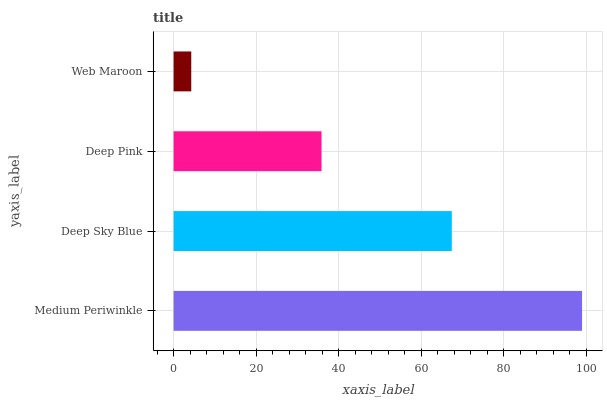Is Web Maroon the minimum?
Answer yes or no. Yes. Is Medium Periwinkle the maximum?
Answer yes or no. Yes. Is Deep Sky Blue the minimum?
Answer yes or no. No. Is Deep Sky Blue the maximum?
Answer yes or no. No. Is Medium Periwinkle greater than Deep Sky Blue?
Answer yes or no. Yes. Is Deep Sky Blue less than Medium Periwinkle?
Answer yes or no. Yes. Is Deep Sky Blue greater than Medium Periwinkle?
Answer yes or no. No. Is Medium Periwinkle less than Deep Sky Blue?
Answer yes or no. No. Is Deep Sky Blue the high median?
Answer yes or no. Yes. Is Deep Pink the low median?
Answer yes or no. Yes. Is Medium Periwinkle the high median?
Answer yes or no. No. Is Web Maroon the low median?
Answer yes or no. No. 